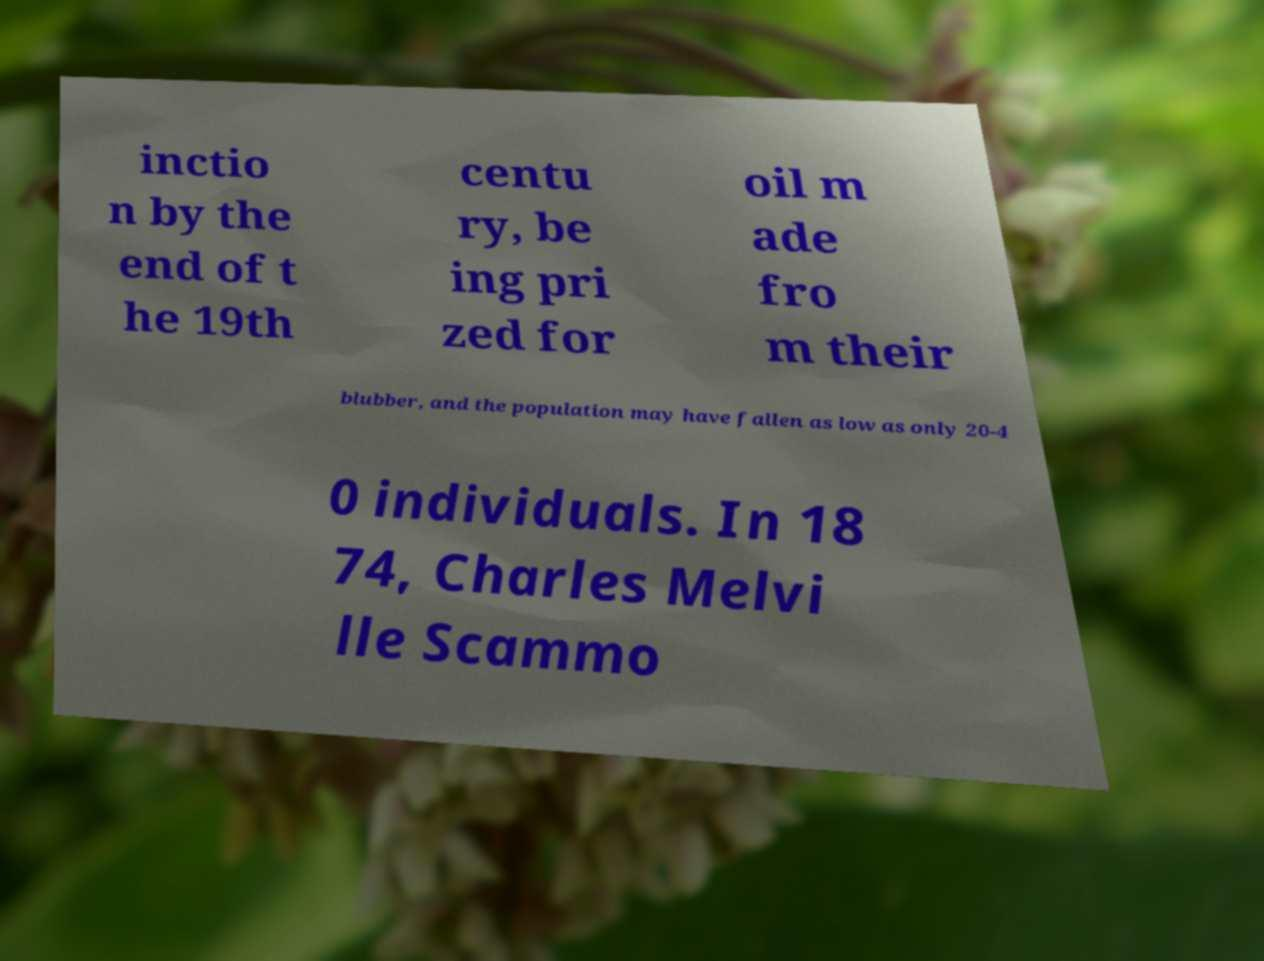Please identify and transcribe the text found in this image. inctio n by the end of t he 19th centu ry, be ing pri zed for oil m ade fro m their blubber, and the population may have fallen as low as only 20-4 0 individuals. In 18 74, Charles Melvi lle Scammo 